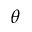<formula> <loc_0><loc_0><loc_500><loc_500>\theta</formula> 